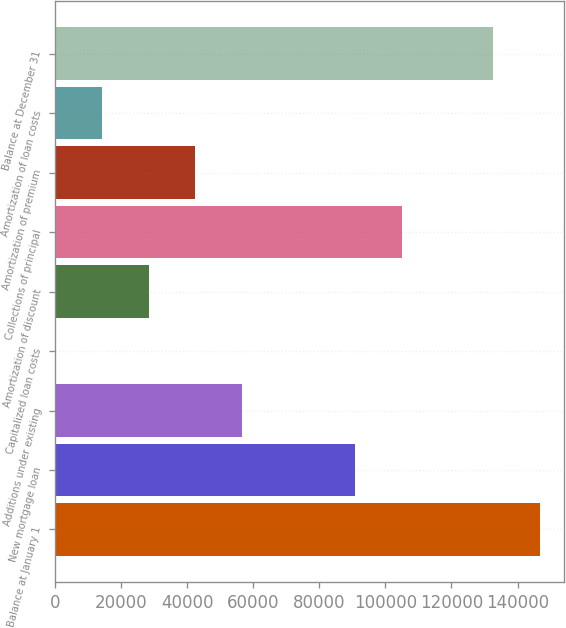<chart> <loc_0><loc_0><loc_500><loc_500><bar_chart><fcel>Balance at January 1<fcel>New mortgage loan<fcel>Additions under existing<fcel>Capitalized loan costs<fcel>Amortization of discount<fcel>Collections of principal<fcel>Amortization of premium<fcel>Amortization of loan costs<fcel>Balance at December 31<nl><fcel>146709<fcel>90886<fcel>56513<fcel>377<fcel>28445<fcel>104920<fcel>42479<fcel>14411<fcel>132675<nl></chart> 